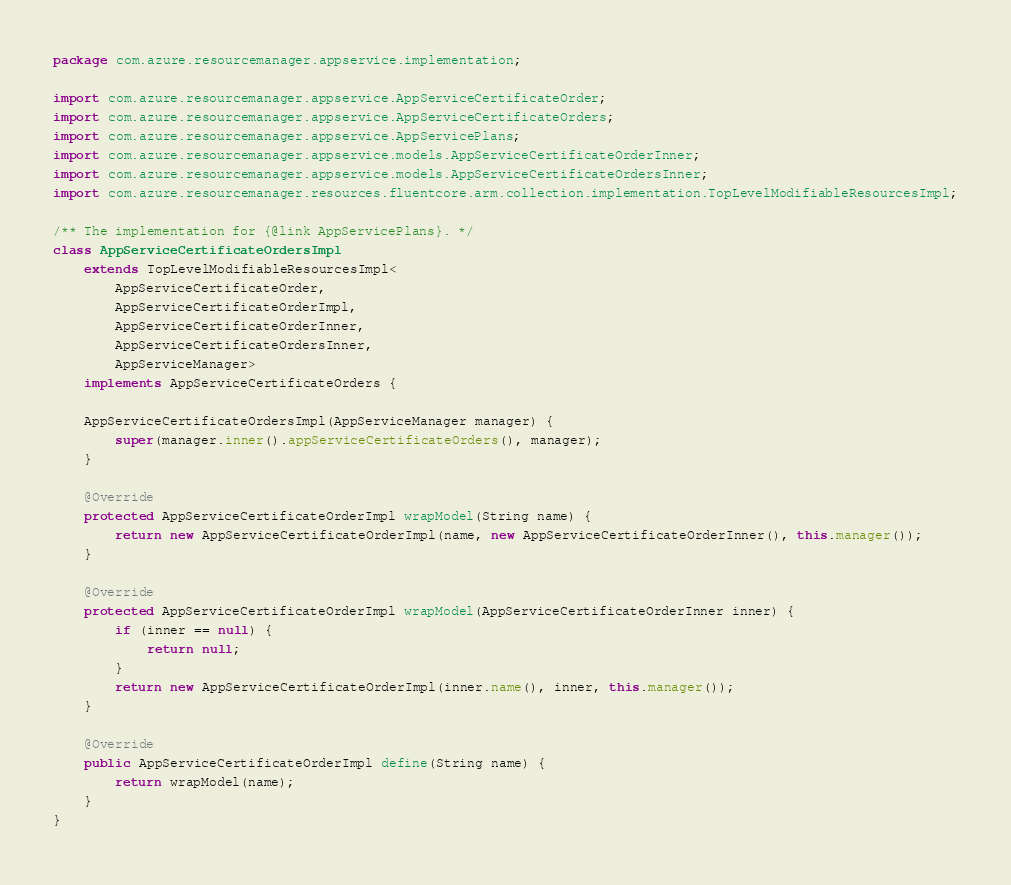<code> <loc_0><loc_0><loc_500><loc_500><_Java_>package com.azure.resourcemanager.appservice.implementation;

import com.azure.resourcemanager.appservice.AppServiceCertificateOrder;
import com.azure.resourcemanager.appservice.AppServiceCertificateOrders;
import com.azure.resourcemanager.appservice.AppServicePlans;
import com.azure.resourcemanager.appservice.models.AppServiceCertificateOrderInner;
import com.azure.resourcemanager.appservice.models.AppServiceCertificateOrdersInner;
import com.azure.resourcemanager.resources.fluentcore.arm.collection.implementation.TopLevelModifiableResourcesImpl;

/** The implementation for {@link AppServicePlans}. */
class AppServiceCertificateOrdersImpl
    extends TopLevelModifiableResourcesImpl<
        AppServiceCertificateOrder,
        AppServiceCertificateOrderImpl,
        AppServiceCertificateOrderInner,
        AppServiceCertificateOrdersInner,
        AppServiceManager>
    implements AppServiceCertificateOrders {

    AppServiceCertificateOrdersImpl(AppServiceManager manager) {
        super(manager.inner().appServiceCertificateOrders(), manager);
    }

    @Override
    protected AppServiceCertificateOrderImpl wrapModel(String name) {
        return new AppServiceCertificateOrderImpl(name, new AppServiceCertificateOrderInner(), this.manager());
    }

    @Override
    protected AppServiceCertificateOrderImpl wrapModel(AppServiceCertificateOrderInner inner) {
        if (inner == null) {
            return null;
        }
        return new AppServiceCertificateOrderImpl(inner.name(), inner, this.manager());
    }

    @Override
    public AppServiceCertificateOrderImpl define(String name) {
        return wrapModel(name);
    }
}
</code> 